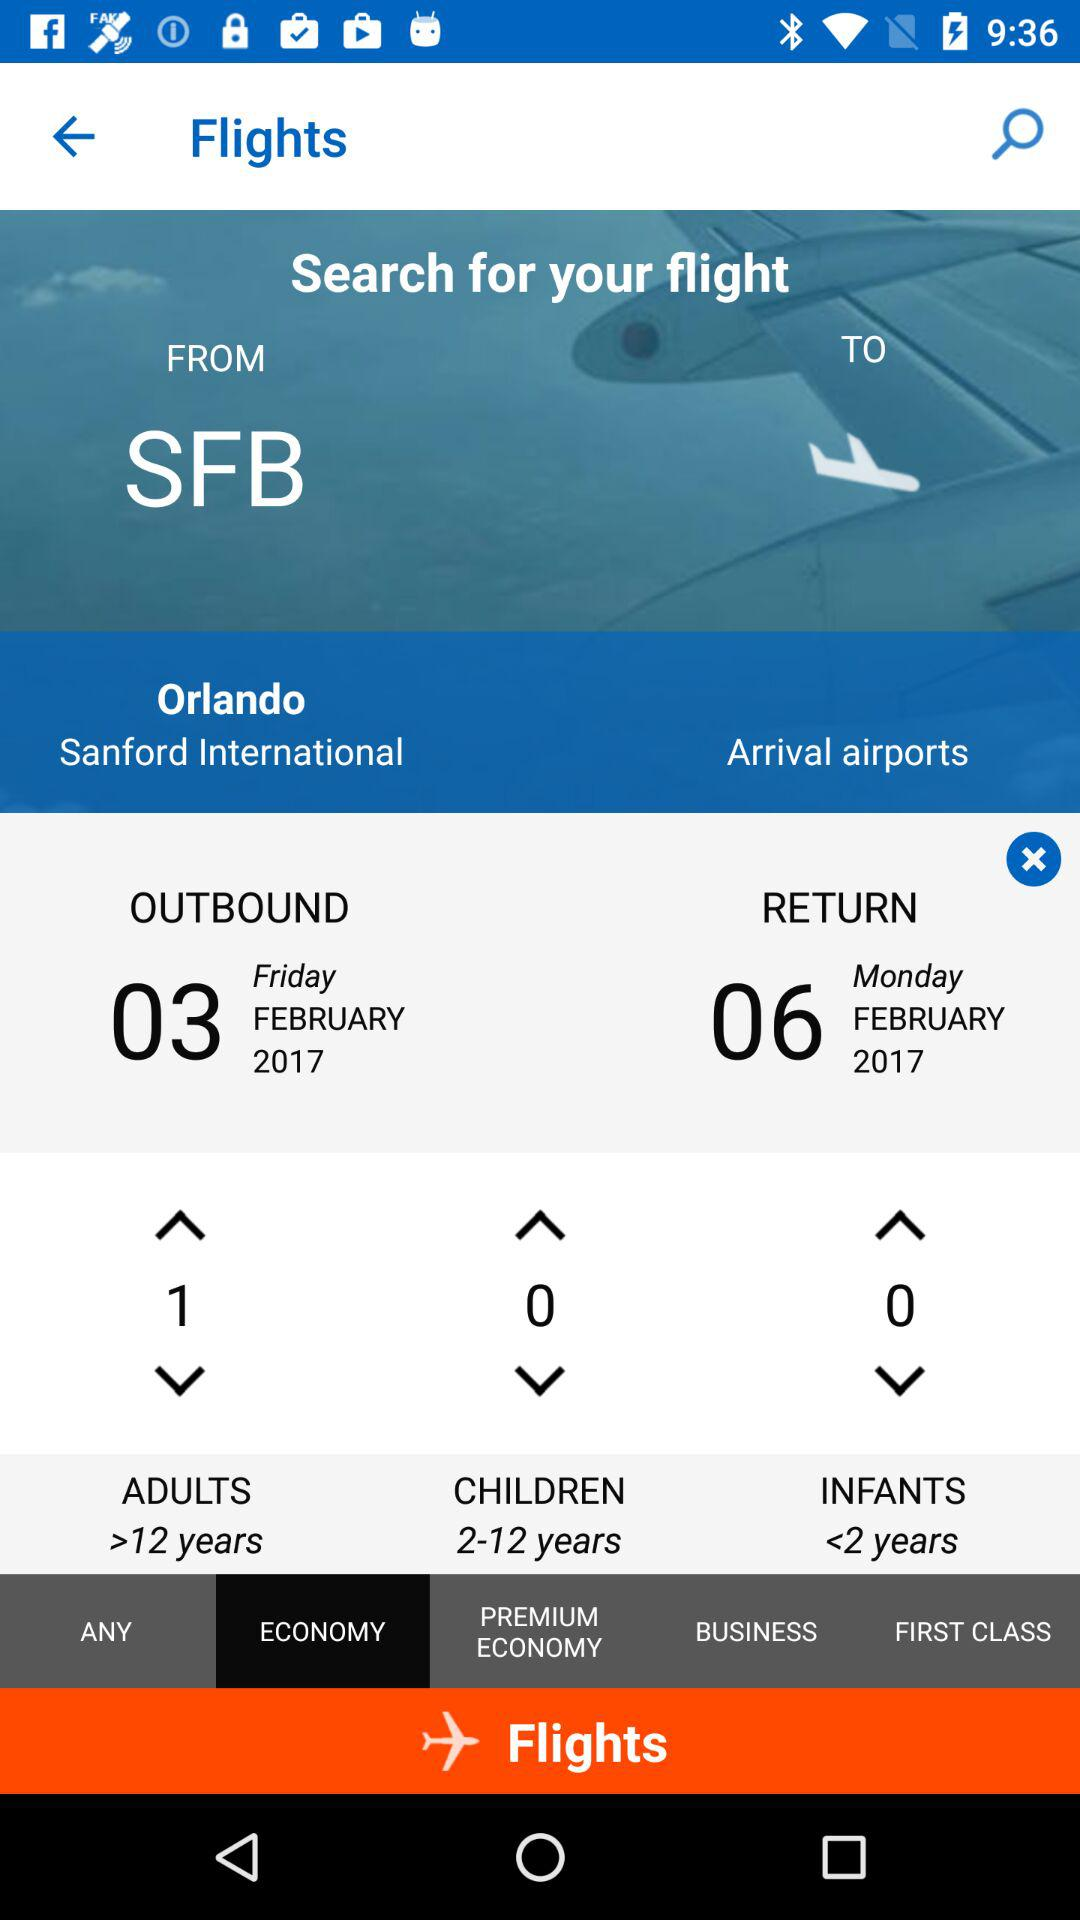What is the return date? The return date is Monday, February 6, 2017. 